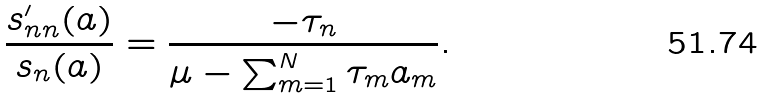<formula> <loc_0><loc_0><loc_500><loc_500>\frac { s ^ { \prime } _ { n n } ( a ) } { s _ { n } ( a ) } = \frac { - \tau _ { n } } { \mu - \sum _ { m = 1 } ^ { N } \tau _ { m } a _ { m } } .</formula> 